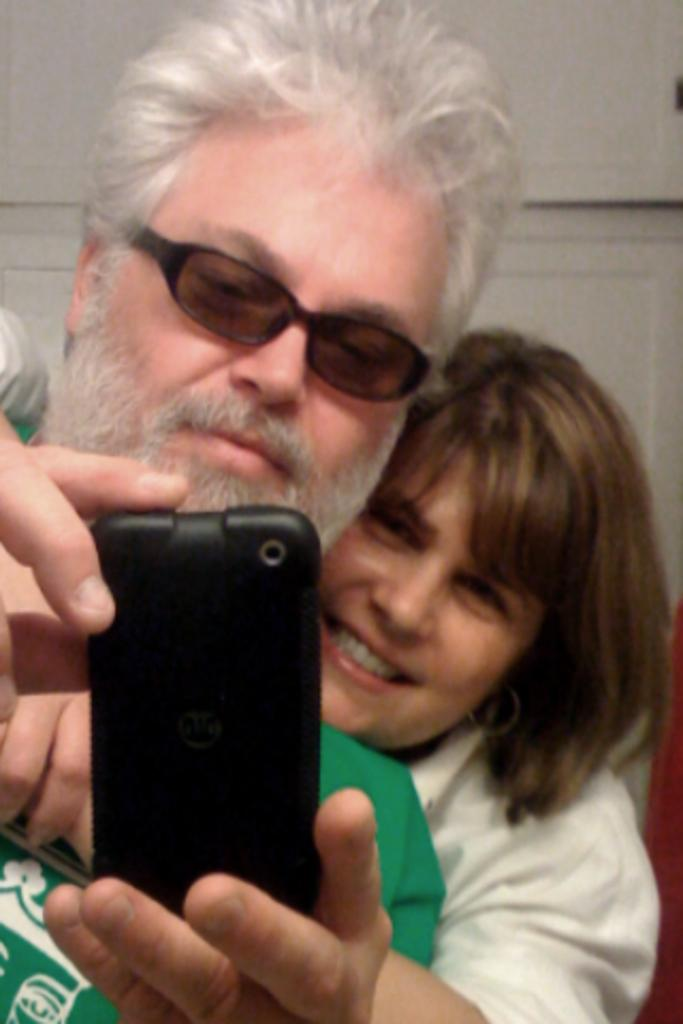How many people are in the image? There are two persons in the image. Can you describe their positions in relation to each other? One person is behind the other. What are the persons holding in their hands? Both persons are holding mobile phones. What can be observed about the person wearing a green shirt? The person wearing a green shirt has spectacles. What type of pain is the person in the image experiencing? There is no indication in the image that either person is experiencing pain. Can you describe the weather conditions in the image? The image does not provide any information about the weather conditions, such as fog. 